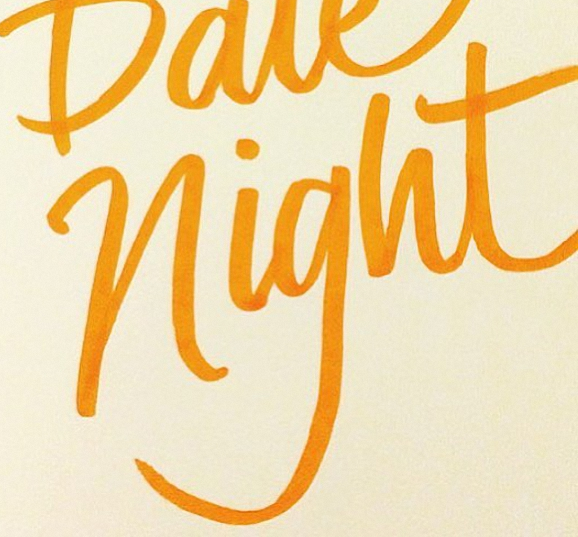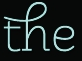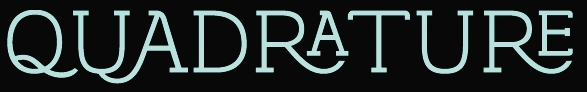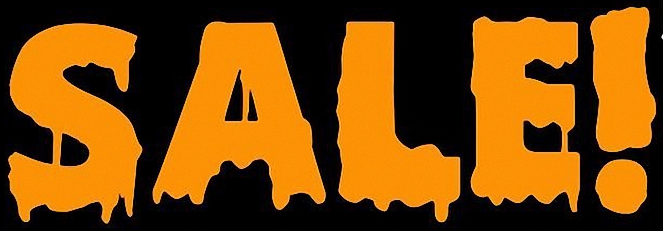What words are shown in these images in order, separated by a semicolon? night; the; QUADRATURE; SALE! 